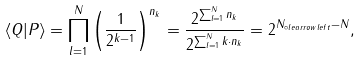<formula> <loc_0><loc_0><loc_500><loc_500>\langle Q | P \rangle = \prod _ { l = 1 } ^ { N } \left ( \frac { 1 } { 2 ^ { k - 1 } } \right ) ^ { n _ { k } } = \frac { 2 ^ { \sum _ { l = 1 } ^ { N } n _ { k } } } { 2 ^ { \sum _ { l = 1 } ^ { N } k \cdot n _ { k } } } = 2 ^ { N _ { \circ l e a r r o w l e f t } - N } ,</formula> 